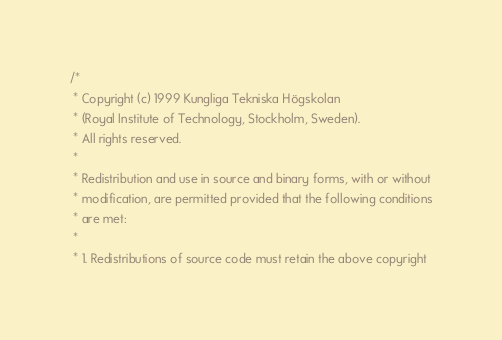Convert code to text. <code><loc_0><loc_0><loc_500><loc_500><_C_>/*
 * Copyright (c) 1999 Kungliga Tekniska Högskolan
 * (Royal Institute of Technology, Stockholm, Sweden).
 * All rights reserved.
 *
 * Redistribution and use in source and binary forms, with or without
 * modification, are permitted provided that the following conditions
 * are met:
 *
 * 1. Redistributions of source code must retain the above copyright</code> 